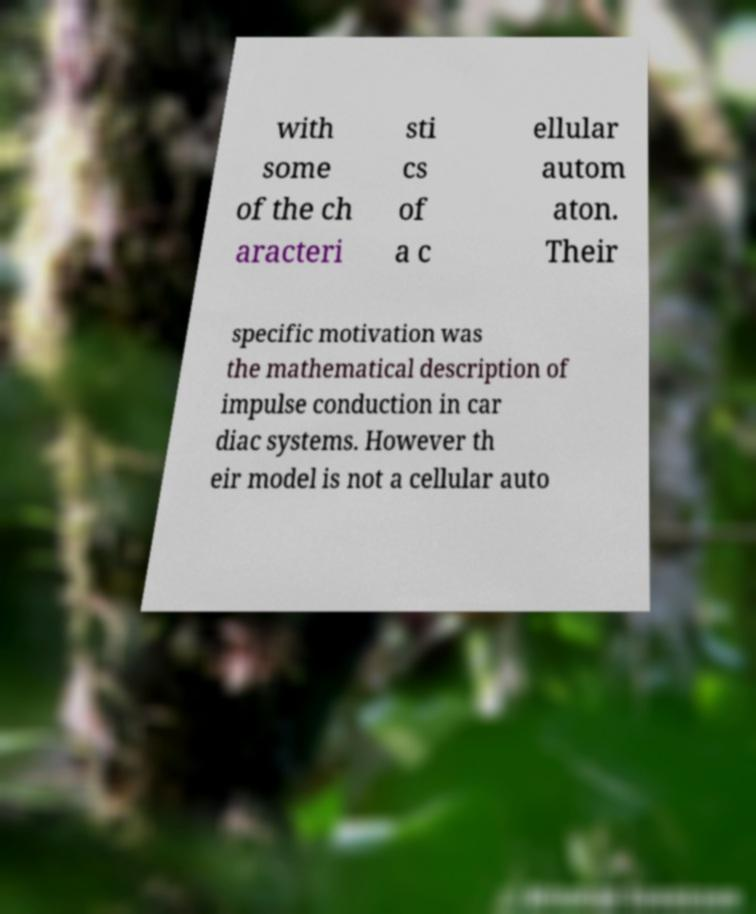Could you assist in decoding the text presented in this image and type it out clearly? with some of the ch aracteri sti cs of a c ellular autom aton. Their specific motivation was the mathematical description of impulse conduction in car diac systems. However th eir model is not a cellular auto 